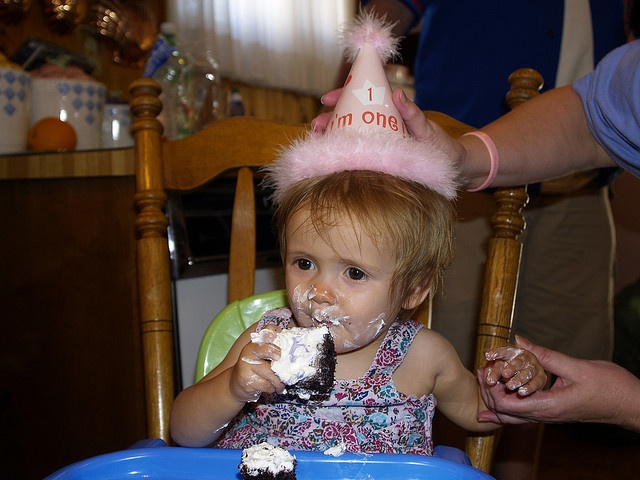Describe the objects in this image and their specific colors. I can see people in black, gray, maroon, and darkgray tones, people in black, maroon, and gray tones, chair in black, maroon, and gray tones, people in black, gray, brown, and maroon tones, and dining table in black, blue, gray, and lightgray tones in this image. 